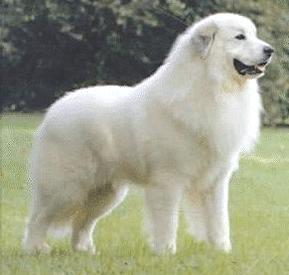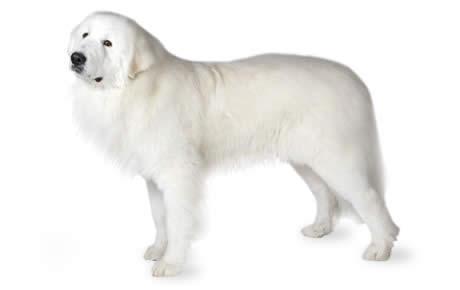The first image is the image on the left, the second image is the image on the right. Evaluate the accuracy of this statement regarding the images: "At least one dog has a brown spot.". Is it true? Answer yes or no. No. 